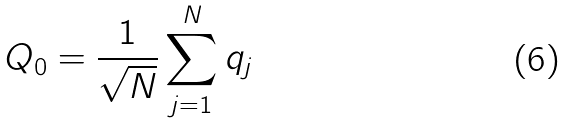<formula> <loc_0><loc_0><loc_500><loc_500>Q _ { 0 } = \frac { 1 } { \sqrt { N } } \sum _ { j = 1 } ^ { N } q _ { j }</formula> 